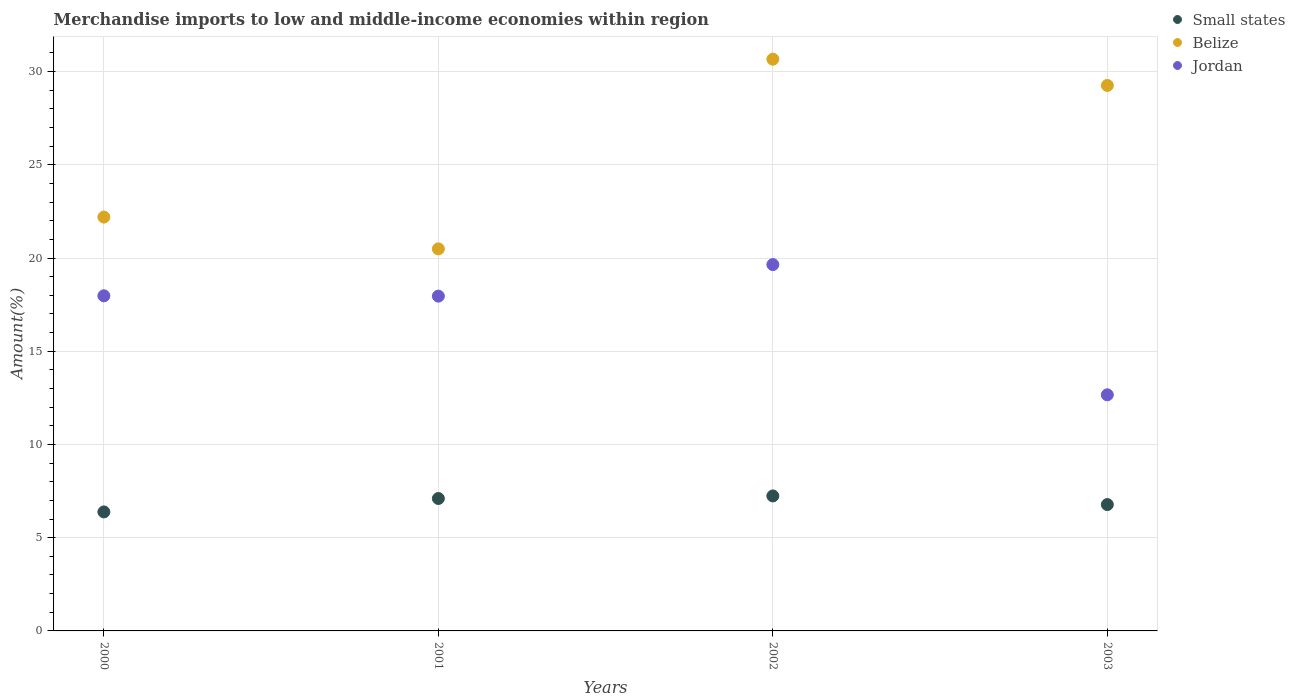Is the number of dotlines equal to the number of legend labels?
Provide a short and direct response. Yes. What is the percentage of amount earned from merchandise imports in Belize in 2002?
Give a very brief answer. 30.67. Across all years, what is the maximum percentage of amount earned from merchandise imports in Jordan?
Your answer should be very brief. 19.65. Across all years, what is the minimum percentage of amount earned from merchandise imports in Belize?
Offer a very short reply. 20.49. In which year was the percentage of amount earned from merchandise imports in Belize minimum?
Offer a very short reply. 2001. What is the total percentage of amount earned from merchandise imports in Jordan in the graph?
Offer a very short reply. 68.25. What is the difference between the percentage of amount earned from merchandise imports in Small states in 2000 and that in 2001?
Give a very brief answer. -0.72. What is the difference between the percentage of amount earned from merchandise imports in Small states in 2003 and the percentage of amount earned from merchandise imports in Jordan in 2001?
Provide a succinct answer. -11.18. What is the average percentage of amount earned from merchandise imports in Small states per year?
Provide a short and direct response. 6.88. In the year 2001, what is the difference between the percentage of amount earned from merchandise imports in Belize and percentage of amount earned from merchandise imports in Small states?
Provide a succinct answer. 13.39. In how many years, is the percentage of amount earned from merchandise imports in Belize greater than 30 %?
Make the answer very short. 1. What is the ratio of the percentage of amount earned from merchandise imports in Jordan in 2000 to that in 2001?
Ensure brevity in your answer.  1. Is the percentage of amount earned from merchandise imports in Small states in 2001 less than that in 2002?
Give a very brief answer. Yes. What is the difference between the highest and the second highest percentage of amount earned from merchandise imports in Jordan?
Your response must be concise. 1.67. What is the difference between the highest and the lowest percentage of amount earned from merchandise imports in Jordan?
Ensure brevity in your answer.  6.99. Is the percentage of amount earned from merchandise imports in Jordan strictly greater than the percentage of amount earned from merchandise imports in Belize over the years?
Offer a very short reply. No. How many dotlines are there?
Make the answer very short. 3. How many years are there in the graph?
Provide a short and direct response. 4. What is the title of the graph?
Offer a very short reply. Merchandise imports to low and middle-income economies within region. What is the label or title of the X-axis?
Keep it short and to the point. Years. What is the label or title of the Y-axis?
Ensure brevity in your answer.  Amount(%). What is the Amount(%) of Small states in 2000?
Ensure brevity in your answer.  6.38. What is the Amount(%) in Belize in 2000?
Offer a very short reply. 22.2. What is the Amount(%) of Jordan in 2000?
Keep it short and to the point. 17.98. What is the Amount(%) of Small states in 2001?
Ensure brevity in your answer.  7.1. What is the Amount(%) of Belize in 2001?
Ensure brevity in your answer.  20.49. What is the Amount(%) of Jordan in 2001?
Give a very brief answer. 17.96. What is the Amount(%) in Small states in 2002?
Offer a terse response. 7.24. What is the Amount(%) in Belize in 2002?
Make the answer very short. 30.67. What is the Amount(%) of Jordan in 2002?
Offer a terse response. 19.65. What is the Amount(%) in Small states in 2003?
Give a very brief answer. 6.78. What is the Amount(%) of Belize in 2003?
Keep it short and to the point. 29.26. What is the Amount(%) in Jordan in 2003?
Provide a short and direct response. 12.66. Across all years, what is the maximum Amount(%) in Small states?
Your answer should be compact. 7.24. Across all years, what is the maximum Amount(%) of Belize?
Provide a short and direct response. 30.67. Across all years, what is the maximum Amount(%) in Jordan?
Give a very brief answer. 19.65. Across all years, what is the minimum Amount(%) of Small states?
Offer a very short reply. 6.38. Across all years, what is the minimum Amount(%) of Belize?
Make the answer very short. 20.49. Across all years, what is the minimum Amount(%) of Jordan?
Offer a very short reply. 12.66. What is the total Amount(%) in Small states in the graph?
Provide a succinct answer. 27.5. What is the total Amount(%) of Belize in the graph?
Provide a succinct answer. 102.62. What is the total Amount(%) in Jordan in the graph?
Provide a succinct answer. 68.25. What is the difference between the Amount(%) of Small states in 2000 and that in 2001?
Provide a succinct answer. -0.72. What is the difference between the Amount(%) in Belize in 2000 and that in 2001?
Your answer should be very brief. 1.71. What is the difference between the Amount(%) of Jordan in 2000 and that in 2001?
Provide a succinct answer. 0.02. What is the difference between the Amount(%) in Small states in 2000 and that in 2002?
Keep it short and to the point. -0.86. What is the difference between the Amount(%) of Belize in 2000 and that in 2002?
Offer a very short reply. -8.47. What is the difference between the Amount(%) of Jordan in 2000 and that in 2002?
Your answer should be compact. -1.67. What is the difference between the Amount(%) in Small states in 2000 and that in 2003?
Make the answer very short. -0.39. What is the difference between the Amount(%) in Belize in 2000 and that in 2003?
Offer a very short reply. -7.06. What is the difference between the Amount(%) of Jordan in 2000 and that in 2003?
Your response must be concise. 5.31. What is the difference between the Amount(%) in Small states in 2001 and that in 2002?
Make the answer very short. -0.14. What is the difference between the Amount(%) in Belize in 2001 and that in 2002?
Offer a terse response. -10.17. What is the difference between the Amount(%) in Jordan in 2001 and that in 2002?
Give a very brief answer. -1.69. What is the difference between the Amount(%) in Small states in 2001 and that in 2003?
Your response must be concise. 0.33. What is the difference between the Amount(%) in Belize in 2001 and that in 2003?
Offer a very short reply. -8.77. What is the difference between the Amount(%) in Jordan in 2001 and that in 2003?
Keep it short and to the point. 5.29. What is the difference between the Amount(%) of Small states in 2002 and that in 2003?
Your answer should be compact. 0.46. What is the difference between the Amount(%) of Belize in 2002 and that in 2003?
Ensure brevity in your answer.  1.41. What is the difference between the Amount(%) in Jordan in 2002 and that in 2003?
Your response must be concise. 6.99. What is the difference between the Amount(%) of Small states in 2000 and the Amount(%) of Belize in 2001?
Make the answer very short. -14.11. What is the difference between the Amount(%) in Small states in 2000 and the Amount(%) in Jordan in 2001?
Keep it short and to the point. -11.57. What is the difference between the Amount(%) in Belize in 2000 and the Amount(%) in Jordan in 2001?
Ensure brevity in your answer.  4.24. What is the difference between the Amount(%) of Small states in 2000 and the Amount(%) of Belize in 2002?
Provide a succinct answer. -24.28. What is the difference between the Amount(%) in Small states in 2000 and the Amount(%) in Jordan in 2002?
Your answer should be compact. -13.27. What is the difference between the Amount(%) in Belize in 2000 and the Amount(%) in Jordan in 2002?
Your answer should be very brief. 2.55. What is the difference between the Amount(%) of Small states in 2000 and the Amount(%) of Belize in 2003?
Your answer should be compact. -22.88. What is the difference between the Amount(%) of Small states in 2000 and the Amount(%) of Jordan in 2003?
Keep it short and to the point. -6.28. What is the difference between the Amount(%) in Belize in 2000 and the Amount(%) in Jordan in 2003?
Keep it short and to the point. 9.53. What is the difference between the Amount(%) in Small states in 2001 and the Amount(%) in Belize in 2002?
Your answer should be compact. -23.56. What is the difference between the Amount(%) in Small states in 2001 and the Amount(%) in Jordan in 2002?
Make the answer very short. -12.55. What is the difference between the Amount(%) of Belize in 2001 and the Amount(%) of Jordan in 2002?
Give a very brief answer. 0.84. What is the difference between the Amount(%) in Small states in 2001 and the Amount(%) in Belize in 2003?
Make the answer very short. -22.16. What is the difference between the Amount(%) in Small states in 2001 and the Amount(%) in Jordan in 2003?
Provide a short and direct response. -5.56. What is the difference between the Amount(%) of Belize in 2001 and the Amount(%) of Jordan in 2003?
Your response must be concise. 7.83. What is the difference between the Amount(%) of Small states in 2002 and the Amount(%) of Belize in 2003?
Give a very brief answer. -22.02. What is the difference between the Amount(%) of Small states in 2002 and the Amount(%) of Jordan in 2003?
Keep it short and to the point. -5.42. What is the difference between the Amount(%) of Belize in 2002 and the Amount(%) of Jordan in 2003?
Keep it short and to the point. 18. What is the average Amount(%) in Small states per year?
Your answer should be compact. 6.88. What is the average Amount(%) in Belize per year?
Your response must be concise. 25.65. What is the average Amount(%) of Jordan per year?
Keep it short and to the point. 17.06. In the year 2000, what is the difference between the Amount(%) of Small states and Amount(%) of Belize?
Keep it short and to the point. -15.82. In the year 2000, what is the difference between the Amount(%) of Small states and Amount(%) of Jordan?
Your answer should be compact. -11.59. In the year 2000, what is the difference between the Amount(%) of Belize and Amount(%) of Jordan?
Keep it short and to the point. 4.22. In the year 2001, what is the difference between the Amount(%) of Small states and Amount(%) of Belize?
Offer a very short reply. -13.39. In the year 2001, what is the difference between the Amount(%) in Small states and Amount(%) in Jordan?
Make the answer very short. -10.85. In the year 2001, what is the difference between the Amount(%) of Belize and Amount(%) of Jordan?
Provide a short and direct response. 2.54. In the year 2002, what is the difference between the Amount(%) of Small states and Amount(%) of Belize?
Your response must be concise. -23.43. In the year 2002, what is the difference between the Amount(%) of Small states and Amount(%) of Jordan?
Your answer should be compact. -12.41. In the year 2002, what is the difference between the Amount(%) of Belize and Amount(%) of Jordan?
Your answer should be compact. 11.02. In the year 2003, what is the difference between the Amount(%) in Small states and Amount(%) in Belize?
Your response must be concise. -22.48. In the year 2003, what is the difference between the Amount(%) of Small states and Amount(%) of Jordan?
Keep it short and to the point. -5.89. In the year 2003, what is the difference between the Amount(%) in Belize and Amount(%) in Jordan?
Offer a very short reply. 16.6. What is the ratio of the Amount(%) in Small states in 2000 to that in 2001?
Provide a short and direct response. 0.9. What is the ratio of the Amount(%) in Belize in 2000 to that in 2001?
Make the answer very short. 1.08. What is the ratio of the Amount(%) in Jordan in 2000 to that in 2001?
Your answer should be compact. 1. What is the ratio of the Amount(%) of Small states in 2000 to that in 2002?
Give a very brief answer. 0.88. What is the ratio of the Amount(%) in Belize in 2000 to that in 2002?
Offer a terse response. 0.72. What is the ratio of the Amount(%) in Jordan in 2000 to that in 2002?
Your response must be concise. 0.91. What is the ratio of the Amount(%) of Small states in 2000 to that in 2003?
Your response must be concise. 0.94. What is the ratio of the Amount(%) of Belize in 2000 to that in 2003?
Offer a very short reply. 0.76. What is the ratio of the Amount(%) of Jordan in 2000 to that in 2003?
Offer a terse response. 1.42. What is the ratio of the Amount(%) of Small states in 2001 to that in 2002?
Your answer should be very brief. 0.98. What is the ratio of the Amount(%) in Belize in 2001 to that in 2002?
Offer a very short reply. 0.67. What is the ratio of the Amount(%) in Jordan in 2001 to that in 2002?
Make the answer very short. 0.91. What is the ratio of the Amount(%) of Small states in 2001 to that in 2003?
Provide a short and direct response. 1.05. What is the ratio of the Amount(%) in Belize in 2001 to that in 2003?
Keep it short and to the point. 0.7. What is the ratio of the Amount(%) in Jordan in 2001 to that in 2003?
Provide a succinct answer. 1.42. What is the ratio of the Amount(%) of Small states in 2002 to that in 2003?
Provide a short and direct response. 1.07. What is the ratio of the Amount(%) in Belize in 2002 to that in 2003?
Make the answer very short. 1.05. What is the ratio of the Amount(%) in Jordan in 2002 to that in 2003?
Your response must be concise. 1.55. What is the difference between the highest and the second highest Amount(%) in Small states?
Ensure brevity in your answer.  0.14. What is the difference between the highest and the second highest Amount(%) in Belize?
Provide a short and direct response. 1.41. What is the difference between the highest and the second highest Amount(%) of Jordan?
Keep it short and to the point. 1.67. What is the difference between the highest and the lowest Amount(%) of Small states?
Make the answer very short. 0.86. What is the difference between the highest and the lowest Amount(%) of Belize?
Keep it short and to the point. 10.17. What is the difference between the highest and the lowest Amount(%) of Jordan?
Offer a very short reply. 6.99. 